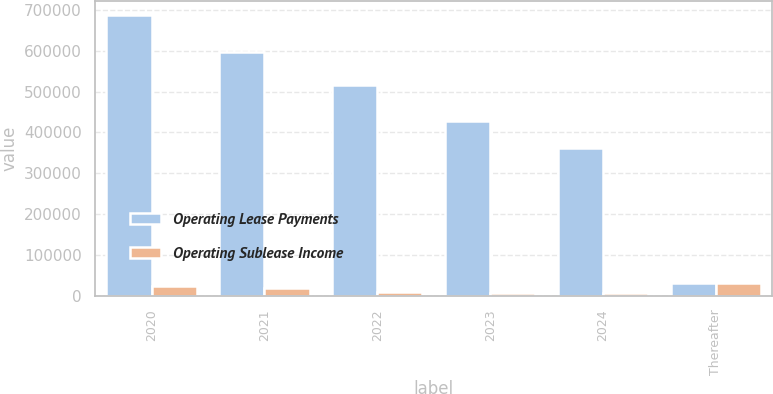<chart> <loc_0><loc_0><loc_500><loc_500><stacked_bar_chart><ecel><fcel>2020<fcel>2021<fcel>2022<fcel>2023<fcel>2024<fcel>Thereafter<nl><fcel>Operating Lease Payments<fcel>688020<fcel>597307<fcel>516544<fcel>428481<fcel>363107<fcel>30708<nl><fcel>Operating Sublease Income<fcel>24884<fcel>17908<fcel>8535<fcel>7541<fcel>7184<fcel>30708<nl></chart> 